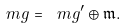<formula> <loc_0><loc_0><loc_500><loc_500>\ m g = \ m g ^ { \prime } \oplus \mathfrak m .</formula> 